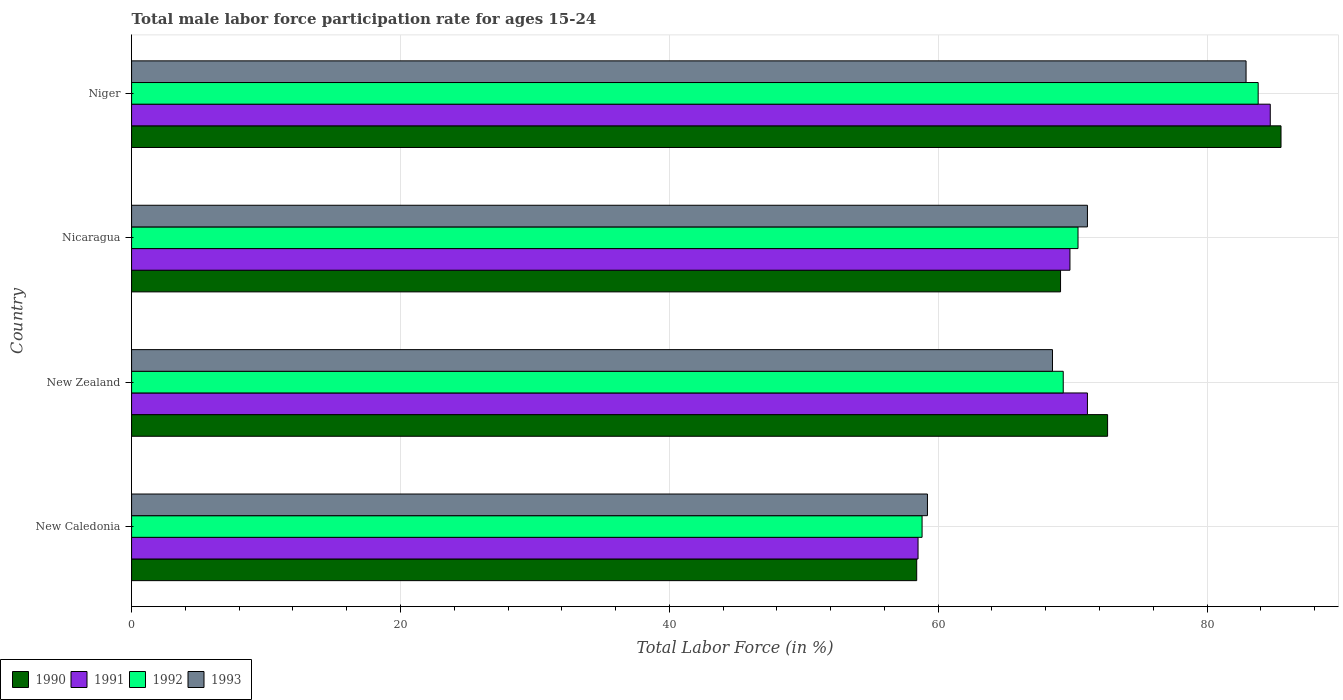Are the number of bars on each tick of the Y-axis equal?
Provide a succinct answer. Yes. What is the label of the 2nd group of bars from the top?
Keep it short and to the point. Nicaragua. What is the male labor force participation rate in 1990 in Niger?
Keep it short and to the point. 85.5. Across all countries, what is the maximum male labor force participation rate in 1993?
Your response must be concise. 82.9. Across all countries, what is the minimum male labor force participation rate in 1990?
Offer a very short reply. 58.4. In which country was the male labor force participation rate in 1992 maximum?
Offer a very short reply. Niger. In which country was the male labor force participation rate in 1990 minimum?
Your answer should be compact. New Caledonia. What is the total male labor force participation rate in 1993 in the graph?
Offer a very short reply. 281.7. What is the difference between the male labor force participation rate in 1990 in Nicaragua and that in Niger?
Your response must be concise. -16.4. What is the difference between the male labor force participation rate in 1991 in New Zealand and the male labor force participation rate in 1992 in New Caledonia?
Give a very brief answer. 12.3. What is the average male labor force participation rate in 1991 per country?
Your response must be concise. 71.02. What is the difference between the male labor force participation rate in 1992 and male labor force participation rate in 1990 in New Caledonia?
Ensure brevity in your answer.  0.4. What is the ratio of the male labor force participation rate in 1992 in New Caledonia to that in New Zealand?
Offer a terse response. 0.85. What is the difference between the highest and the second highest male labor force participation rate in 1991?
Give a very brief answer. 13.6. What is the difference between the highest and the lowest male labor force participation rate in 1991?
Offer a very short reply. 26.2. Is the sum of the male labor force participation rate in 1993 in New Caledonia and Nicaragua greater than the maximum male labor force participation rate in 1990 across all countries?
Your answer should be very brief. Yes. What does the 4th bar from the top in New Caledonia represents?
Your answer should be compact. 1990. How many bars are there?
Your answer should be very brief. 16. Does the graph contain grids?
Provide a short and direct response. Yes. How are the legend labels stacked?
Give a very brief answer. Horizontal. What is the title of the graph?
Keep it short and to the point. Total male labor force participation rate for ages 15-24. Does "1978" appear as one of the legend labels in the graph?
Give a very brief answer. No. What is the Total Labor Force (in %) in 1990 in New Caledonia?
Provide a short and direct response. 58.4. What is the Total Labor Force (in %) of 1991 in New Caledonia?
Offer a terse response. 58.5. What is the Total Labor Force (in %) in 1992 in New Caledonia?
Provide a succinct answer. 58.8. What is the Total Labor Force (in %) in 1993 in New Caledonia?
Offer a very short reply. 59.2. What is the Total Labor Force (in %) in 1990 in New Zealand?
Your response must be concise. 72.6. What is the Total Labor Force (in %) in 1991 in New Zealand?
Offer a very short reply. 71.1. What is the Total Labor Force (in %) of 1992 in New Zealand?
Offer a very short reply. 69.3. What is the Total Labor Force (in %) of 1993 in New Zealand?
Keep it short and to the point. 68.5. What is the Total Labor Force (in %) in 1990 in Nicaragua?
Provide a short and direct response. 69.1. What is the Total Labor Force (in %) in 1991 in Nicaragua?
Your answer should be compact. 69.8. What is the Total Labor Force (in %) of 1992 in Nicaragua?
Make the answer very short. 70.4. What is the Total Labor Force (in %) of 1993 in Nicaragua?
Your answer should be very brief. 71.1. What is the Total Labor Force (in %) in 1990 in Niger?
Give a very brief answer. 85.5. What is the Total Labor Force (in %) of 1991 in Niger?
Provide a succinct answer. 84.7. What is the Total Labor Force (in %) in 1992 in Niger?
Your response must be concise. 83.8. What is the Total Labor Force (in %) in 1993 in Niger?
Your answer should be compact. 82.9. Across all countries, what is the maximum Total Labor Force (in %) of 1990?
Your answer should be very brief. 85.5. Across all countries, what is the maximum Total Labor Force (in %) in 1991?
Ensure brevity in your answer.  84.7. Across all countries, what is the maximum Total Labor Force (in %) of 1992?
Offer a terse response. 83.8. Across all countries, what is the maximum Total Labor Force (in %) in 1993?
Provide a succinct answer. 82.9. Across all countries, what is the minimum Total Labor Force (in %) in 1990?
Provide a short and direct response. 58.4. Across all countries, what is the minimum Total Labor Force (in %) of 1991?
Ensure brevity in your answer.  58.5. Across all countries, what is the minimum Total Labor Force (in %) in 1992?
Offer a very short reply. 58.8. Across all countries, what is the minimum Total Labor Force (in %) of 1993?
Give a very brief answer. 59.2. What is the total Total Labor Force (in %) in 1990 in the graph?
Offer a terse response. 285.6. What is the total Total Labor Force (in %) of 1991 in the graph?
Ensure brevity in your answer.  284.1. What is the total Total Labor Force (in %) of 1992 in the graph?
Offer a terse response. 282.3. What is the total Total Labor Force (in %) in 1993 in the graph?
Give a very brief answer. 281.7. What is the difference between the Total Labor Force (in %) in 1990 in New Caledonia and that in New Zealand?
Provide a succinct answer. -14.2. What is the difference between the Total Labor Force (in %) in 1991 in New Caledonia and that in New Zealand?
Your response must be concise. -12.6. What is the difference between the Total Labor Force (in %) of 1990 in New Caledonia and that in Nicaragua?
Offer a terse response. -10.7. What is the difference between the Total Labor Force (in %) of 1991 in New Caledonia and that in Nicaragua?
Keep it short and to the point. -11.3. What is the difference between the Total Labor Force (in %) of 1993 in New Caledonia and that in Nicaragua?
Give a very brief answer. -11.9. What is the difference between the Total Labor Force (in %) in 1990 in New Caledonia and that in Niger?
Ensure brevity in your answer.  -27.1. What is the difference between the Total Labor Force (in %) in 1991 in New Caledonia and that in Niger?
Offer a very short reply. -26.2. What is the difference between the Total Labor Force (in %) of 1992 in New Caledonia and that in Niger?
Your answer should be very brief. -25. What is the difference between the Total Labor Force (in %) of 1993 in New Caledonia and that in Niger?
Ensure brevity in your answer.  -23.7. What is the difference between the Total Labor Force (in %) in 1992 in New Zealand and that in Niger?
Keep it short and to the point. -14.5. What is the difference between the Total Labor Force (in %) in 1993 in New Zealand and that in Niger?
Give a very brief answer. -14.4. What is the difference between the Total Labor Force (in %) of 1990 in Nicaragua and that in Niger?
Give a very brief answer. -16.4. What is the difference between the Total Labor Force (in %) of 1991 in Nicaragua and that in Niger?
Provide a succinct answer. -14.9. What is the difference between the Total Labor Force (in %) in 1990 in New Caledonia and the Total Labor Force (in %) in 1991 in New Zealand?
Make the answer very short. -12.7. What is the difference between the Total Labor Force (in %) in 1990 in New Caledonia and the Total Labor Force (in %) in 1993 in New Zealand?
Ensure brevity in your answer.  -10.1. What is the difference between the Total Labor Force (in %) of 1991 in New Caledonia and the Total Labor Force (in %) of 1992 in New Zealand?
Your response must be concise. -10.8. What is the difference between the Total Labor Force (in %) of 1991 in New Caledonia and the Total Labor Force (in %) of 1993 in New Zealand?
Offer a terse response. -10. What is the difference between the Total Labor Force (in %) of 1992 in New Caledonia and the Total Labor Force (in %) of 1993 in New Zealand?
Your answer should be compact. -9.7. What is the difference between the Total Labor Force (in %) of 1990 in New Caledonia and the Total Labor Force (in %) of 1991 in Nicaragua?
Offer a terse response. -11.4. What is the difference between the Total Labor Force (in %) of 1990 in New Caledonia and the Total Labor Force (in %) of 1992 in Nicaragua?
Ensure brevity in your answer.  -12. What is the difference between the Total Labor Force (in %) of 1990 in New Caledonia and the Total Labor Force (in %) of 1993 in Nicaragua?
Your answer should be compact. -12.7. What is the difference between the Total Labor Force (in %) in 1992 in New Caledonia and the Total Labor Force (in %) in 1993 in Nicaragua?
Offer a very short reply. -12.3. What is the difference between the Total Labor Force (in %) of 1990 in New Caledonia and the Total Labor Force (in %) of 1991 in Niger?
Your answer should be very brief. -26.3. What is the difference between the Total Labor Force (in %) in 1990 in New Caledonia and the Total Labor Force (in %) in 1992 in Niger?
Ensure brevity in your answer.  -25.4. What is the difference between the Total Labor Force (in %) in 1990 in New Caledonia and the Total Labor Force (in %) in 1993 in Niger?
Provide a short and direct response. -24.5. What is the difference between the Total Labor Force (in %) in 1991 in New Caledonia and the Total Labor Force (in %) in 1992 in Niger?
Your response must be concise. -25.3. What is the difference between the Total Labor Force (in %) in 1991 in New Caledonia and the Total Labor Force (in %) in 1993 in Niger?
Your response must be concise. -24.4. What is the difference between the Total Labor Force (in %) in 1992 in New Caledonia and the Total Labor Force (in %) in 1993 in Niger?
Your answer should be very brief. -24.1. What is the difference between the Total Labor Force (in %) in 1990 in New Zealand and the Total Labor Force (in %) in 1992 in Nicaragua?
Make the answer very short. 2.2. What is the difference between the Total Labor Force (in %) in 1990 in New Zealand and the Total Labor Force (in %) in 1993 in Nicaragua?
Give a very brief answer. 1.5. What is the difference between the Total Labor Force (in %) of 1991 in New Zealand and the Total Labor Force (in %) of 1992 in Nicaragua?
Your response must be concise. 0.7. What is the difference between the Total Labor Force (in %) in 1990 in New Zealand and the Total Labor Force (in %) in 1991 in Niger?
Ensure brevity in your answer.  -12.1. What is the difference between the Total Labor Force (in %) in 1990 in New Zealand and the Total Labor Force (in %) in 1993 in Niger?
Ensure brevity in your answer.  -10.3. What is the difference between the Total Labor Force (in %) in 1991 in New Zealand and the Total Labor Force (in %) in 1992 in Niger?
Give a very brief answer. -12.7. What is the difference between the Total Labor Force (in %) in 1991 in New Zealand and the Total Labor Force (in %) in 1993 in Niger?
Your answer should be very brief. -11.8. What is the difference between the Total Labor Force (in %) in 1992 in New Zealand and the Total Labor Force (in %) in 1993 in Niger?
Provide a succinct answer. -13.6. What is the difference between the Total Labor Force (in %) of 1990 in Nicaragua and the Total Labor Force (in %) of 1991 in Niger?
Your answer should be very brief. -15.6. What is the difference between the Total Labor Force (in %) of 1990 in Nicaragua and the Total Labor Force (in %) of 1992 in Niger?
Your response must be concise. -14.7. What is the difference between the Total Labor Force (in %) of 1990 in Nicaragua and the Total Labor Force (in %) of 1993 in Niger?
Provide a short and direct response. -13.8. What is the difference between the Total Labor Force (in %) in 1991 in Nicaragua and the Total Labor Force (in %) in 1992 in Niger?
Your response must be concise. -14. What is the difference between the Total Labor Force (in %) in 1992 in Nicaragua and the Total Labor Force (in %) in 1993 in Niger?
Keep it short and to the point. -12.5. What is the average Total Labor Force (in %) of 1990 per country?
Your answer should be compact. 71.4. What is the average Total Labor Force (in %) of 1991 per country?
Make the answer very short. 71.03. What is the average Total Labor Force (in %) of 1992 per country?
Provide a short and direct response. 70.58. What is the average Total Labor Force (in %) of 1993 per country?
Provide a short and direct response. 70.42. What is the difference between the Total Labor Force (in %) of 1990 and Total Labor Force (in %) of 1991 in New Caledonia?
Your answer should be compact. -0.1. What is the difference between the Total Labor Force (in %) in 1990 and Total Labor Force (in %) in 1992 in New Caledonia?
Provide a succinct answer. -0.4. What is the difference between the Total Labor Force (in %) of 1991 and Total Labor Force (in %) of 1992 in New Caledonia?
Your response must be concise. -0.3. What is the difference between the Total Labor Force (in %) of 1992 and Total Labor Force (in %) of 1993 in New Caledonia?
Ensure brevity in your answer.  -0.4. What is the difference between the Total Labor Force (in %) of 1990 and Total Labor Force (in %) of 1993 in New Zealand?
Give a very brief answer. 4.1. What is the difference between the Total Labor Force (in %) in 1992 and Total Labor Force (in %) in 1993 in New Zealand?
Your response must be concise. 0.8. What is the difference between the Total Labor Force (in %) of 1990 and Total Labor Force (in %) of 1992 in Nicaragua?
Provide a succinct answer. -1.3. What is the difference between the Total Labor Force (in %) of 1990 and Total Labor Force (in %) of 1993 in Nicaragua?
Provide a short and direct response. -2. What is the difference between the Total Labor Force (in %) in 1991 and Total Labor Force (in %) in 1993 in Nicaragua?
Offer a very short reply. -1.3. What is the difference between the Total Labor Force (in %) of 1992 and Total Labor Force (in %) of 1993 in Nicaragua?
Provide a succinct answer. -0.7. What is the difference between the Total Labor Force (in %) in 1990 and Total Labor Force (in %) in 1992 in Niger?
Make the answer very short. 1.7. What is the difference between the Total Labor Force (in %) of 1990 and Total Labor Force (in %) of 1993 in Niger?
Your answer should be very brief. 2.6. What is the difference between the Total Labor Force (in %) in 1991 and Total Labor Force (in %) in 1993 in Niger?
Make the answer very short. 1.8. What is the ratio of the Total Labor Force (in %) in 1990 in New Caledonia to that in New Zealand?
Keep it short and to the point. 0.8. What is the ratio of the Total Labor Force (in %) in 1991 in New Caledonia to that in New Zealand?
Your response must be concise. 0.82. What is the ratio of the Total Labor Force (in %) of 1992 in New Caledonia to that in New Zealand?
Make the answer very short. 0.85. What is the ratio of the Total Labor Force (in %) in 1993 in New Caledonia to that in New Zealand?
Make the answer very short. 0.86. What is the ratio of the Total Labor Force (in %) of 1990 in New Caledonia to that in Nicaragua?
Your answer should be very brief. 0.85. What is the ratio of the Total Labor Force (in %) in 1991 in New Caledonia to that in Nicaragua?
Keep it short and to the point. 0.84. What is the ratio of the Total Labor Force (in %) of 1992 in New Caledonia to that in Nicaragua?
Provide a succinct answer. 0.84. What is the ratio of the Total Labor Force (in %) in 1993 in New Caledonia to that in Nicaragua?
Keep it short and to the point. 0.83. What is the ratio of the Total Labor Force (in %) of 1990 in New Caledonia to that in Niger?
Ensure brevity in your answer.  0.68. What is the ratio of the Total Labor Force (in %) in 1991 in New Caledonia to that in Niger?
Keep it short and to the point. 0.69. What is the ratio of the Total Labor Force (in %) in 1992 in New Caledonia to that in Niger?
Offer a terse response. 0.7. What is the ratio of the Total Labor Force (in %) in 1993 in New Caledonia to that in Niger?
Make the answer very short. 0.71. What is the ratio of the Total Labor Force (in %) in 1990 in New Zealand to that in Nicaragua?
Provide a succinct answer. 1.05. What is the ratio of the Total Labor Force (in %) of 1991 in New Zealand to that in Nicaragua?
Offer a very short reply. 1.02. What is the ratio of the Total Labor Force (in %) in 1992 in New Zealand to that in Nicaragua?
Your answer should be very brief. 0.98. What is the ratio of the Total Labor Force (in %) in 1993 in New Zealand to that in Nicaragua?
Offer a terse response. 0.96. What is the ratio of the Total Labor Force (in %) in 1990 in New Zealand to that in Niger?
Your answer should be very brief. 0.85. What is the ratio of the Total Labor Force (in %) of 1991 in New Zealand to that in Niger?
Your answer should be compact. 0.84. What is the ratio of the Total Labor Force (in %) of 1992 in New Zealand to that in Niger?
Your response must be concise. 0.83. What is the ratio of the Total Labor Force (in %) of 1993 in New Zealand to that in Niger?
Ensure brevity in your answer.  0.83. What is the ratio of the Total Labor Force (in %) in 1990 in Nicaragua to that in Niger?
Provide a short and direct response. 0.81. What is the ratio of the Total Labor Force (in %) in 1991 in Nicaragua to that in Niger?
Your response must be concise. 0.82. What is the ratio of the Total Labor Force (in %) of 1992 in Nicaragua to that in Niger?
Keep it short and to the point. 0.84. What is the ratio of the Total Labor Force (in %) of 1993 in Nicaragua to that in Niger?
Your response must be concise. 0.86. What is the difference between the highest and the second highest Total Labor Force (in %) in 1991?
Provide a succinct answer. 13.6. What is the difference between the highest and the second highest Total Labor Force (in %) in 1993?
Give a very brief answer. 11.8. What is the difference between the highest and the lowest Total Labor Force (in %) in 1990?
Your response must be concise. 27.1. What is the difference between the highest and the lowest Total Labor Force (in %) in 1991?
Keep it short and to the point. 26.2. What is the difference between the highest and the lowest Total Labor Force (in %) of 1992?
Give a very brief answer. 25. What is the difference between the highest and the lowest Total Labor Force (in %) in 1993?
Keep it short and to the point. 23.7. 